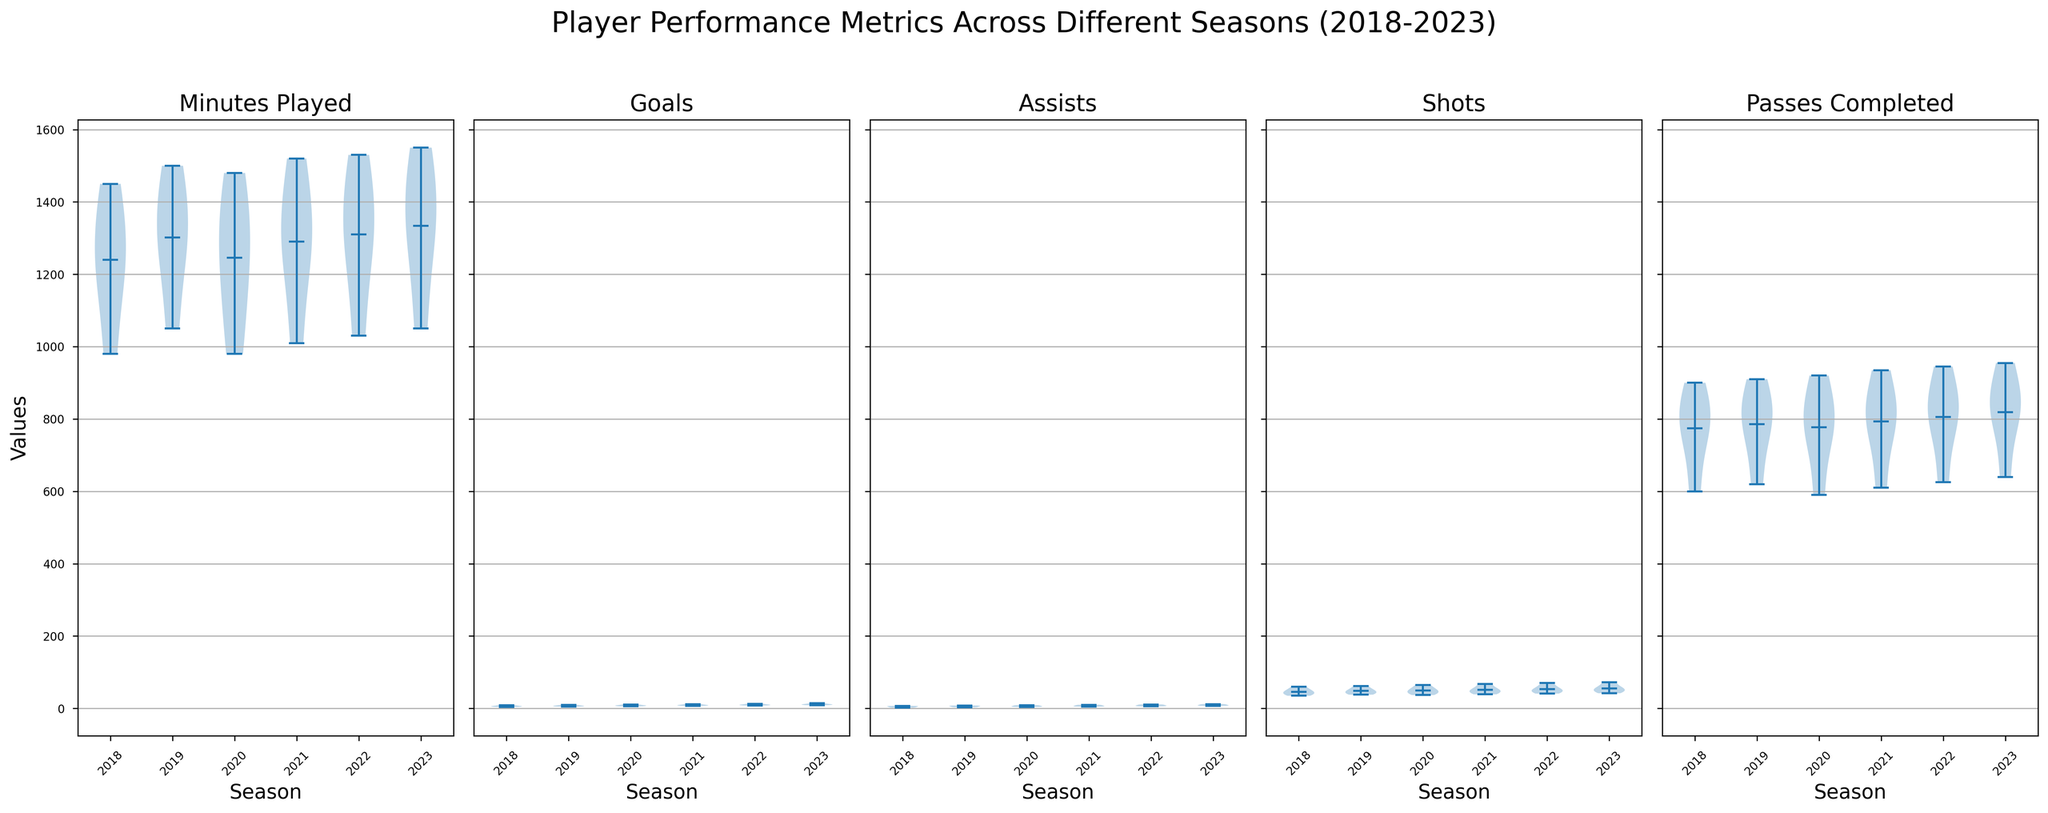What's the overall trend in "Goals" from 2018 to 2023? By observing the violin plots of "Goals" for each season, you can see if there is a general increase or decrease in the distribution centre and spread over the years. Identify how the mean, median, and spread change across the seasons.
Answer: The trend for "Goals" seems to be increasing from 2018 to 2023 Which season displayed the highest variability in "Shots"? Variability in a violin plot can be assessed by the width of the plot at different points. The wider the plot, the higher the variability. Check for the season with the broadest "Shots" plot.
Answer: 2023 displayed the highest variability in "Shots" What is the mean "Assists" value for 2023, and how does it compare to the mean "Assists" value in 2018? Look for the white dot within the violin plot for "Assists" in 2023 and 2018, representing the mean value. Compare these two values to answer the question.
Answer: The mean "Assists" in 2023 is higher than that in 2018 In which season did players have the highest median "Minutes Played"? Find the black bar in each "Minutes Played" violin plot representing the median value. Compare the medians across seasons to identify the highest.
Answer: 2023 had the highest median "Minutes Played" How did the distribution of "Passes Completed" evolve from 2018 to 2023? Analyze the shape, spread, and central tendency depicted in the violin plots of "Passes Completed" over the seasons. Note any consistent shifts in mean and spread.
Answer: "Passes Completed" generally increased in central tendency from 2018 to 2023 Is there a visible difference between the median number of "Goals" in 2021 compared to 2020? Compare the black bars in the "Goals" violin plots for 2021 and 2020. Identify whether there's a noticeable difference in their positions.
Answer: The median number of "Goals" in 2021 is higher than in 2020 Between which years did "Assists" show the most notable increase? Examine the position and spread of the "Assists" violin plots year-over-year to identify a significant rise in central tendency or distribution.
Answer: The most notable increase in "Assists" was between 2018 and 2019 Which metric showed the most consistent performance across all seasons? Assess the violin plots for each metric, looking for the one with the least variation and most stable central tendency over the years.
Answer: "Minutes Played" showed the most consistent performance How does the median "Shots" in 2019 compare to that in 2022? Identify the black bars in the "Shots" violin plot for 2019 and 2022, which represent the median values, and compare their heights.
Answer: The median "Shots" in 2022 is higher than in 2019 What can you infer about the variability in "Minutes Played" across the seasons? Look at the width of the violin plots for "Minutes Played" across each season. Assess whether the variability increases, decreases, or remains relatively constant.
Answer: The variability in "Minutes Played" remains relatively constant across the seasons 